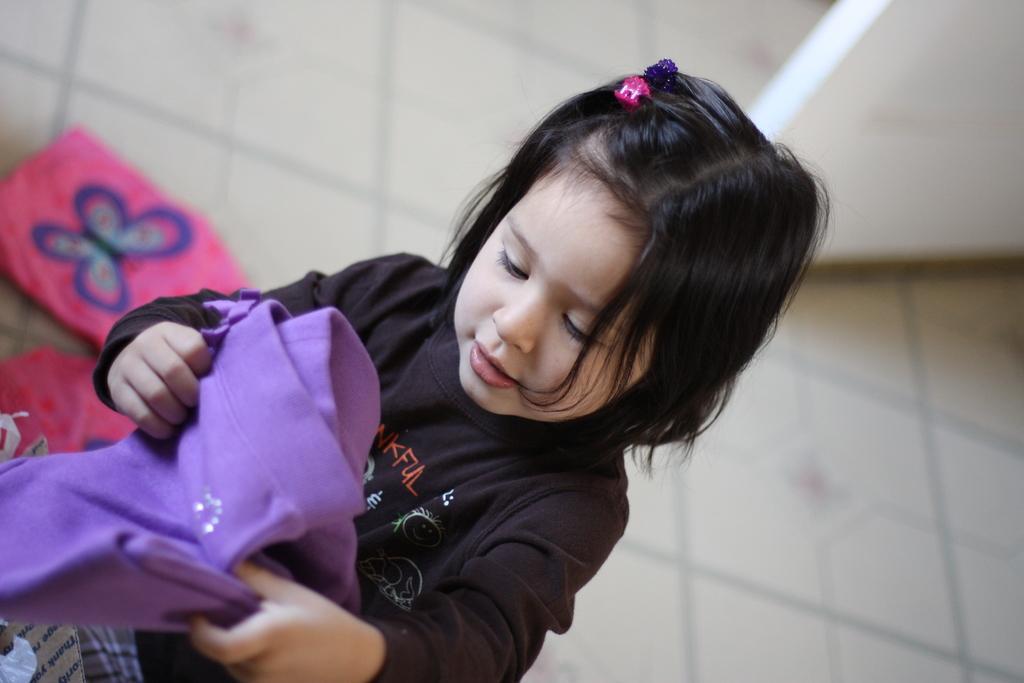Can you describe this image briefly? In this image I can see a baby girl wearing black color dress is holding a purple colored cloth in her hand. I can see the floor, a pink colored cloth on the floor and a wall in the background. 